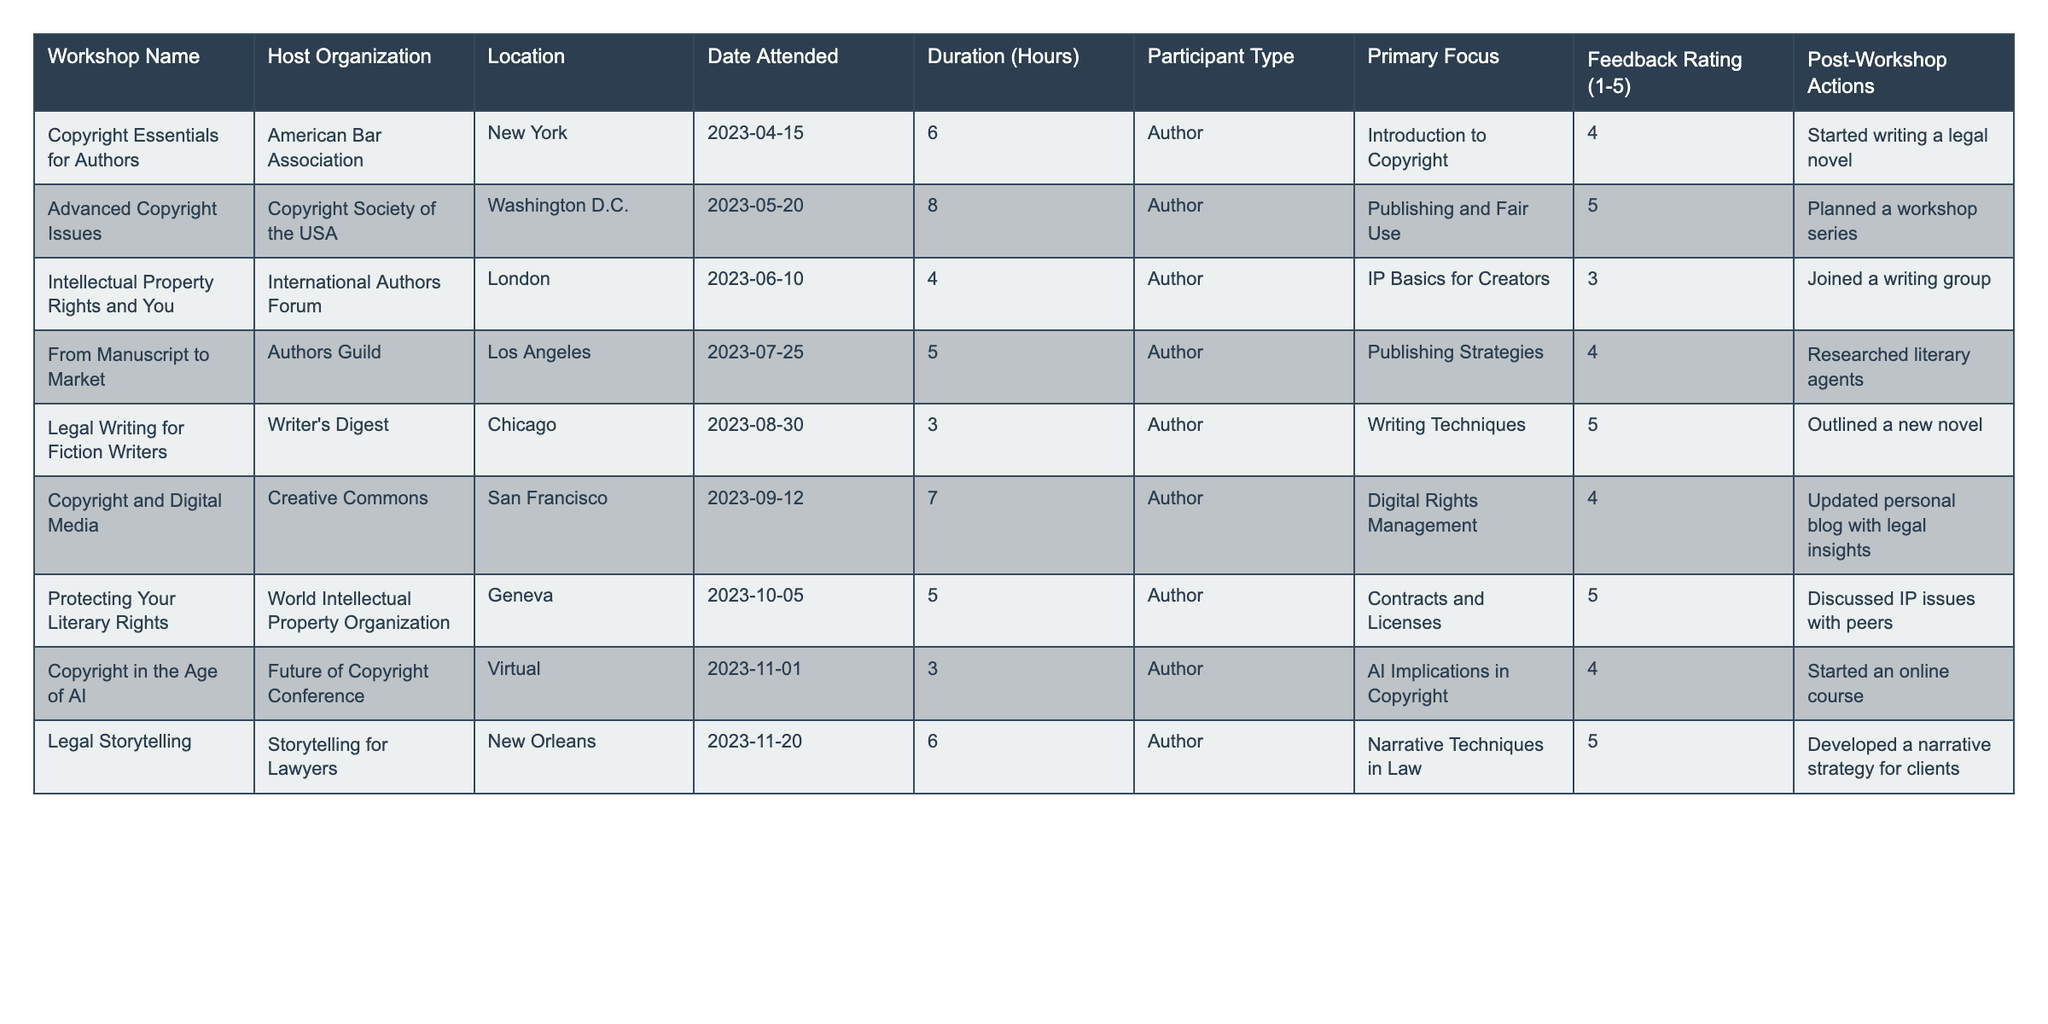What is the feedback rating for the workshop "Legal Writing for Fiction Writers"? The feedback rating for the workshop titled "Legal Writing for Fiction Writers" is specified in the table and corresponds to the value listed under the "Feedback Rating (1-5)" column for that workshop, which is 5.
Answer: 5 Which workshop focused on "Publishing Strategies"? By checking the "Primary Focus" column in the table, we find that the workshop named "From Manuscript to Market" had a primary focus on "Publishing Strategies."
Answer: From Manuscript to Market What is the average duration of the workshops attended? To find the average duration, sum all the durations listed in the "Duration (Hours)" column (6 + 8 + 4 + 5 + 3 + 7 + 5 + 3 + 6 = 47) and then divide by the number of workshops (9). Therefore, the average duration is 47/9 ≈ 5.22 hours.
Answer: ≈ 5.22 hours Did the participant who attended "Copyright in the Age of AI" take an action after the workshop? The "Post-Workshop Actions" column indicates that the participant started an online course after attending the "Copyright in the Age of AI" workshop, confirming that they did take action.
Answer: Yes Which workshop had the highest feedback rating? To determine the workshop with the highest feedback rating, we review the "Feedback Rating (1-5)" column values and note that the workshops "Advanced Copyright Issues," "Legal Writing for Fiction Writers," and "Protecting Your Literary Rights" all received a rating of 5, which is the highest.
Answer: Advanced Copyright Issues, Legal Writing for Fiction Writers, Protecting Your Literary Rights What total number of participants focused on "Digital Rights Management"? In the table, the only workshop that mentioned "Digital Rights Management" as its focus is "Copyright and Digital Media," and it had one participant type, which is "Author." Therefore, the total number of participants focusing on that topic is 1.
Answer: 1 How many workshops took place in New York? Looking at the "Location" column, we identify that only one workshop, "Copyright Essentials for Authors," is held in New York. Hence, the total number of workshops in that location is 1.
Answer: 1 What action did participants mostly want to take after attending copyright workshops? Observing the "Post-Workshop Actions" column, it is noted that actions include starting writing projects, planning series, joining groups, and developing strategies. However, the most common theme relates to actions focused on writing or outlining new content, indicating that many participants intended to further their writing activities.
Answer: Writing-related actions Which participant attended multiple workshops with a focus on writing techniques? By reviewing the "Primary Focus" and "Participant Type," we find that the "Legal Writing for Fiction Writers" workshop specifically focuses on writing techniques attended by an author. However, this data alone does not guarantee any participant attended multiple workshops specifically on writing techniques without additional details on the same author. Thus, it's not applicable based on this table alone.
Answer: Not applicable Is there a workshop that covered both copyright issues and narrative techniques? Analyzing the table, "Legal Writing for Fiction Writers" addresses narrative techniques without linking it to copyright. No single workshop combined both themes as defined in the provided data.
Answer: No 